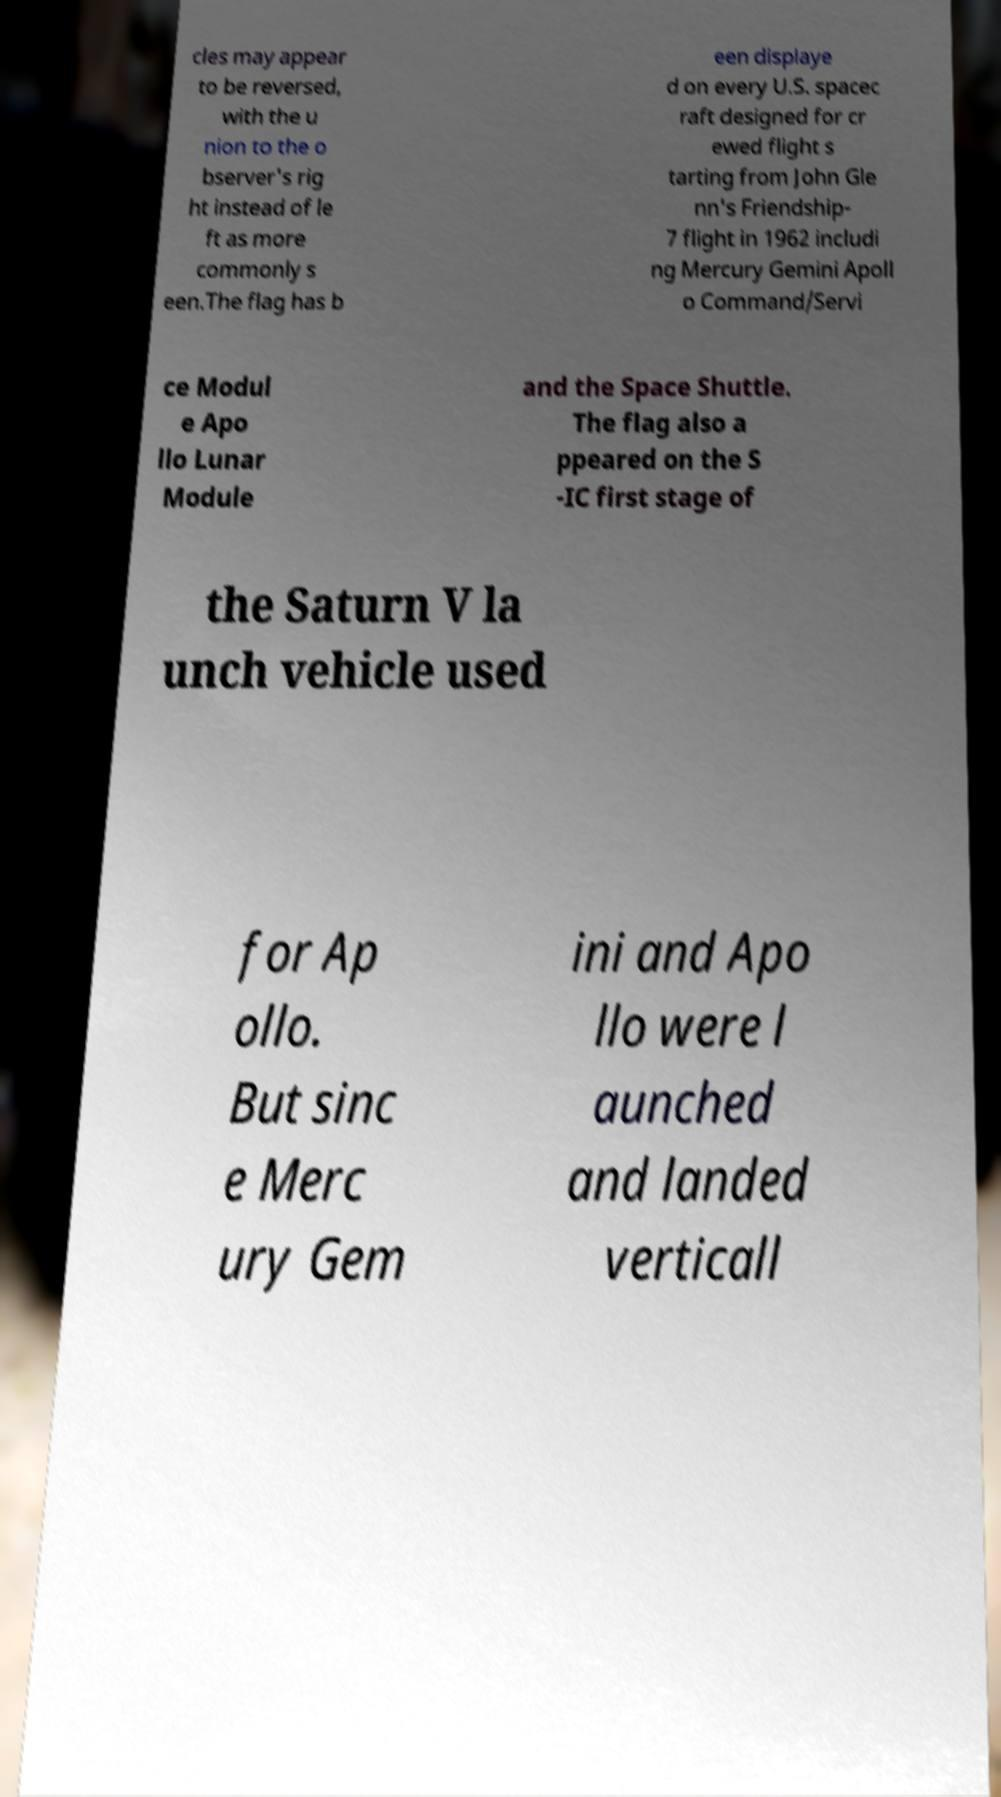What messages or text are displayed in this image? I need them in a readable, typed format. cles may appear to be reversed, with the u nion to the o bserver's rig ht instead of le ft as more commonly s een.The flag has b een displaye d on every U.S. spacec raft designed for cr ewed flight s tarting from John Gle nn's Friendship- 7 flight in 1962 includi ng Mercury Gemini Apoll o Command/Servi ce Modul e Apo llo Lunar Module and the Space Shuttle. The flag also a ppeared on the S -IC first stage of the Saturn V la unch vehicle used for Ap ollo. But sinc e Merc ury Gem ini and Apo llo were l aunched and landed verticall 